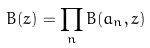<formula> <loc_0><loc_0><loc_500><loc_500>B ( z ) = \prod _ { n } B ( a _ { n } , z )</formula> 